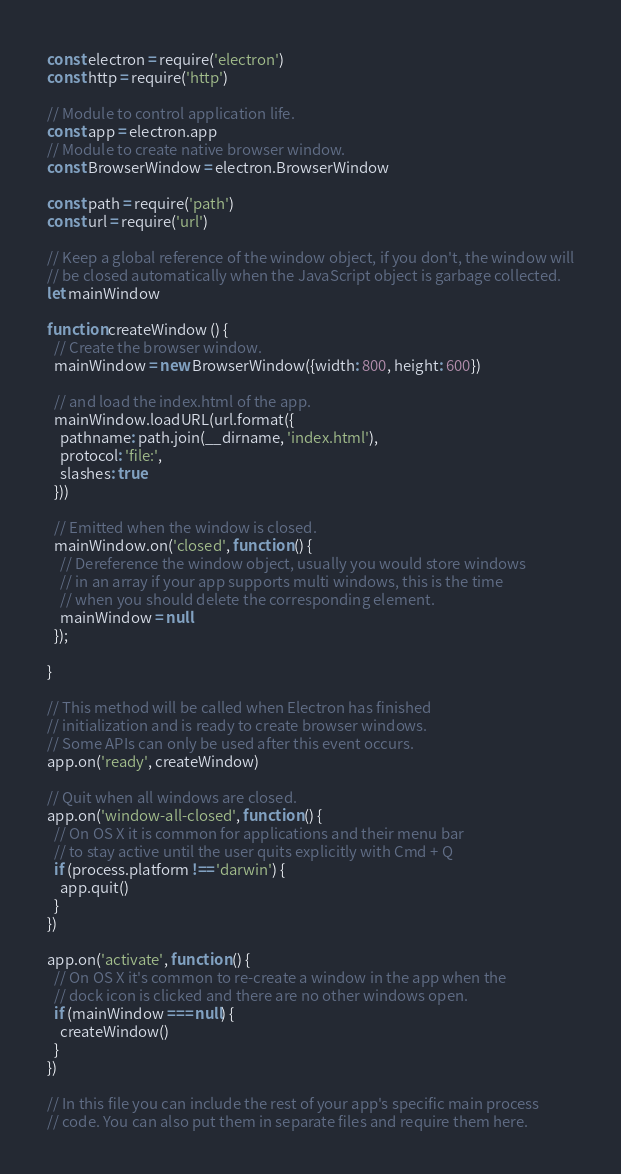<code> <loc_0><loc_0><loc_500><loc_500><_JavaScript_>const electron = require('electron')
const http = require('http')

// Module to control application life.
const app = electron.app
// Module to create native browser window.
const BrowserWindow = electron.BrowserWindow

const path = require('path')
const url = require('url')

// Keep a global reference of the window object, if you don't, the window will
// be closed automatically when the JavaScript object is garbage collected.
let mainWindow

function createWindow () {
  // Create the browser window.
  mainWindow = new BrowserWindow({width: 800, height: 600})

  // and load the index.html of the app.
  mainWindow.loadURL(url.format({
    pathname: path.join(__dirname, 'index.html'),
    protocol: 'file:',
    slashes: true
  }))

  // Emitted when the window is closed.
  mainWindow.on('closed', function () {
    // Dereference the window object, usually you would store windows
    // in an array if your app supports multi windows, this is the time
    // when you should delete the corresponding element.
    mainWindow = null
  });

}

// This method will be called when Electron has finished
// initialization and is ready to create browser windows.
// Some APIs can only be used after this event occurs.
app.on('ready', createWindow)

// Quit when all windows are closed.
app.on('window-all-closed', function () {
  // On OS X it is common for applications and their menu bar
  // to stay active until the user quits explicitly with Cmd + Q
  if (process.platform !== 'darwin') {
    app.quit()
  }
})

app.on('activate', function () {
  // On OS X it's common to re-create a window in the app when the
  // dock icon is clicked and there are no other windows open.
  if (mainWindow === null) {
    createWindow()
  }
})

// In this file you can include the rest of your app's specific main process
// code. You can also put them in separate files and require them here.
</code> 